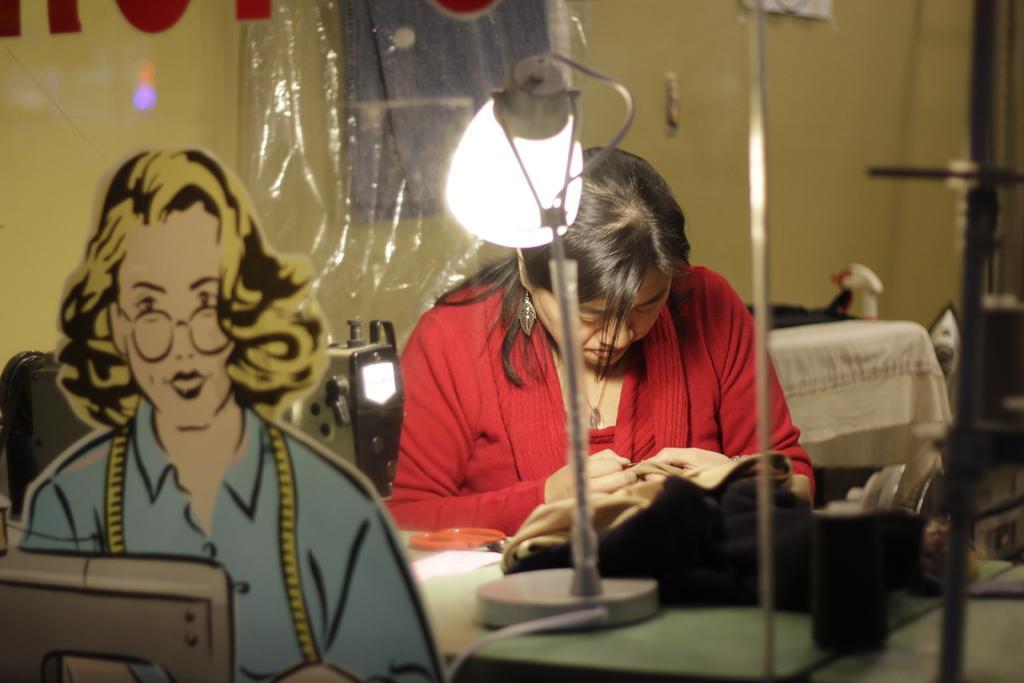In one or two sentences, can you explain what this image depicts? In this picture I can observe a woman in the middle of the picture. She is wearing red color dress. In front of her I can observe a lamp on the table. In the background I can observe wall. 